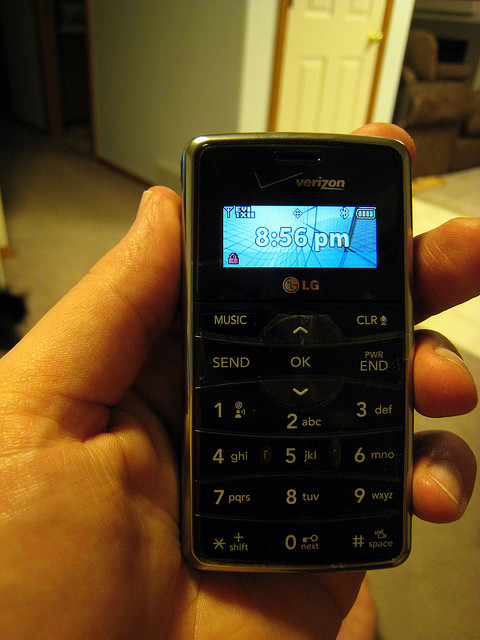Identify the text contained in this image. 8:56 pm 1 2 3 def abc mno wxyz tuv jkl ghi pqrs 7 shift space nex 0 8 9 6 5 4 MUSIC SEND OK END PWR CLR LG verizon 